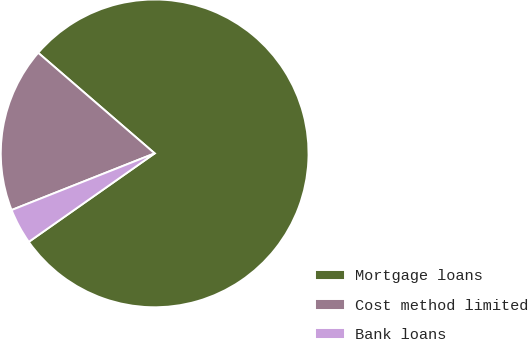Convert chart to OTSL. <chart><loc_0><loc_0><loc_500><loc_500><pie_chart><fcel>Mortgage loans<fcel>Cost method limited<fcel>Bank loans<nl><fcel>78.91%<fcel>17.34%<fcel>3.75%<nl></chart> 